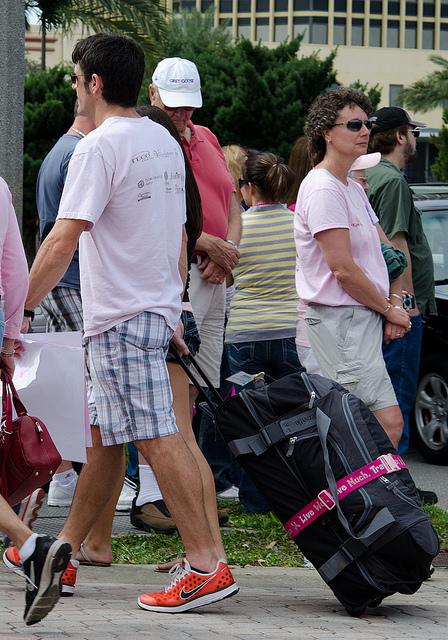Is one of the men shirtless?
Keep it brief. No. Does the guy in the middle have a ball?
Quick response, please. No. What color is the suitcase?
Quick response, please. Black. What object is next to purse of the lady with the hat?
Concise answer only. Suitcase. Is the weather warm?
Write a very short answer. Yes. How old is this boy?
Quick response, please. 18. Is this scene happening during the day?
Concise answer only. Yes. 